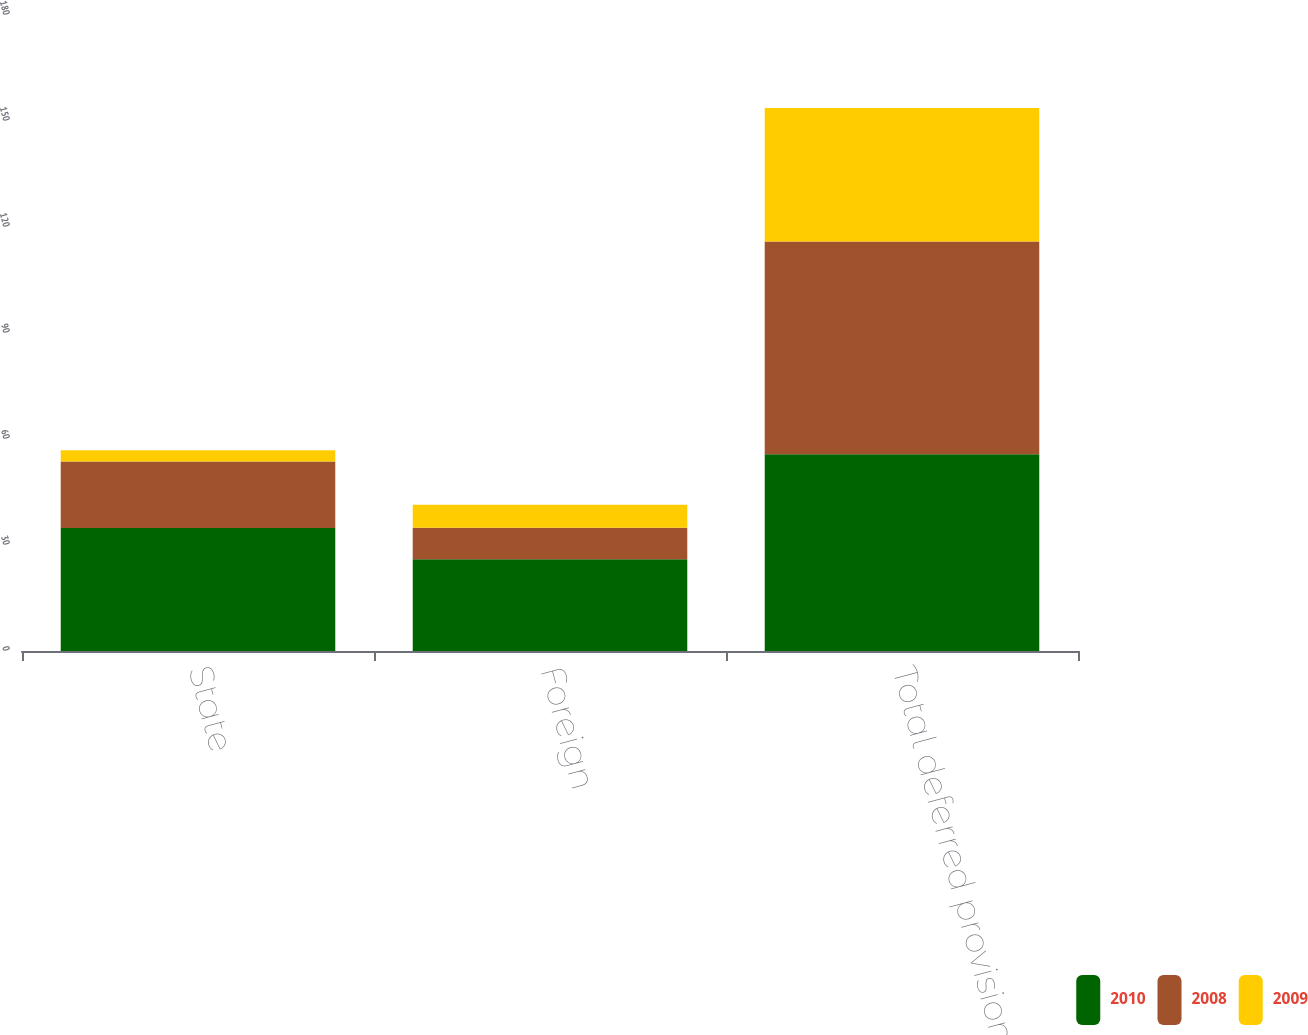Convert chart to OTSL. <chart><loc_0><loc_0><loc_500><loc_500><stacked_bar_chart><ecel><fcel>State<fcel>Foreign<fcel>Total deferred provision<nl><fcel>2010<fcel>34.8<fcel>26<fcel>55.7<nl><fcel>2008<fcel>18.8<fcel>8.9<fcel>60.2<nl><fcel>2009<fcel>3.2<fcel>6.5<fcel>37.8<nl></chart> 